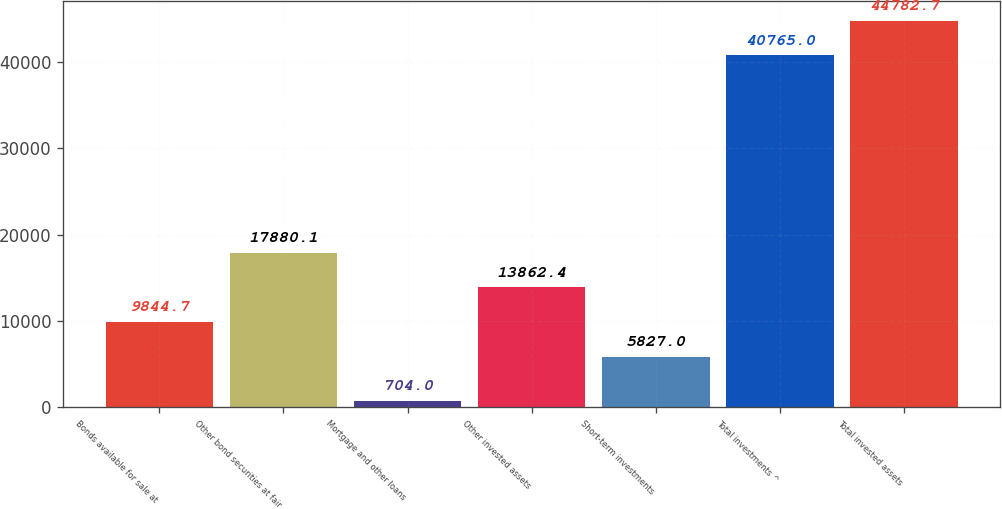<chart> <loc_0><loc_0><loc_500><loc_500><bar_chart><fcel>Bonds available for sale at<fcel>Other bond securities at fair<fcel>Mortgage and other loans<fcel>Other invested assets<fcel>Short-term investments<fcel>Total investments ^<fcel>Total invested assets<nl><fcel>9844.7<fcel>17880.1<fcel>704<fcel>13862.4<fcel>5827<fcel>40765<fcel>44782.7<nl></chart> 